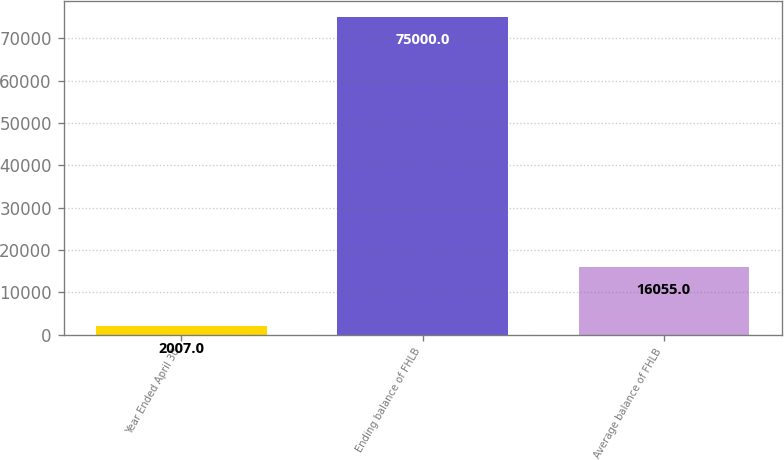Convert chart to OTSL. <chart><loc_0><loc_0><loc_500><loc_500><bar_chart><fcel>Year Ended April 30<fcel>Ending balance of FHLB<fcel>Average balance of FHLB<nl><fcel>2007<fcel>75000<fcel>16055<nl></chart> 